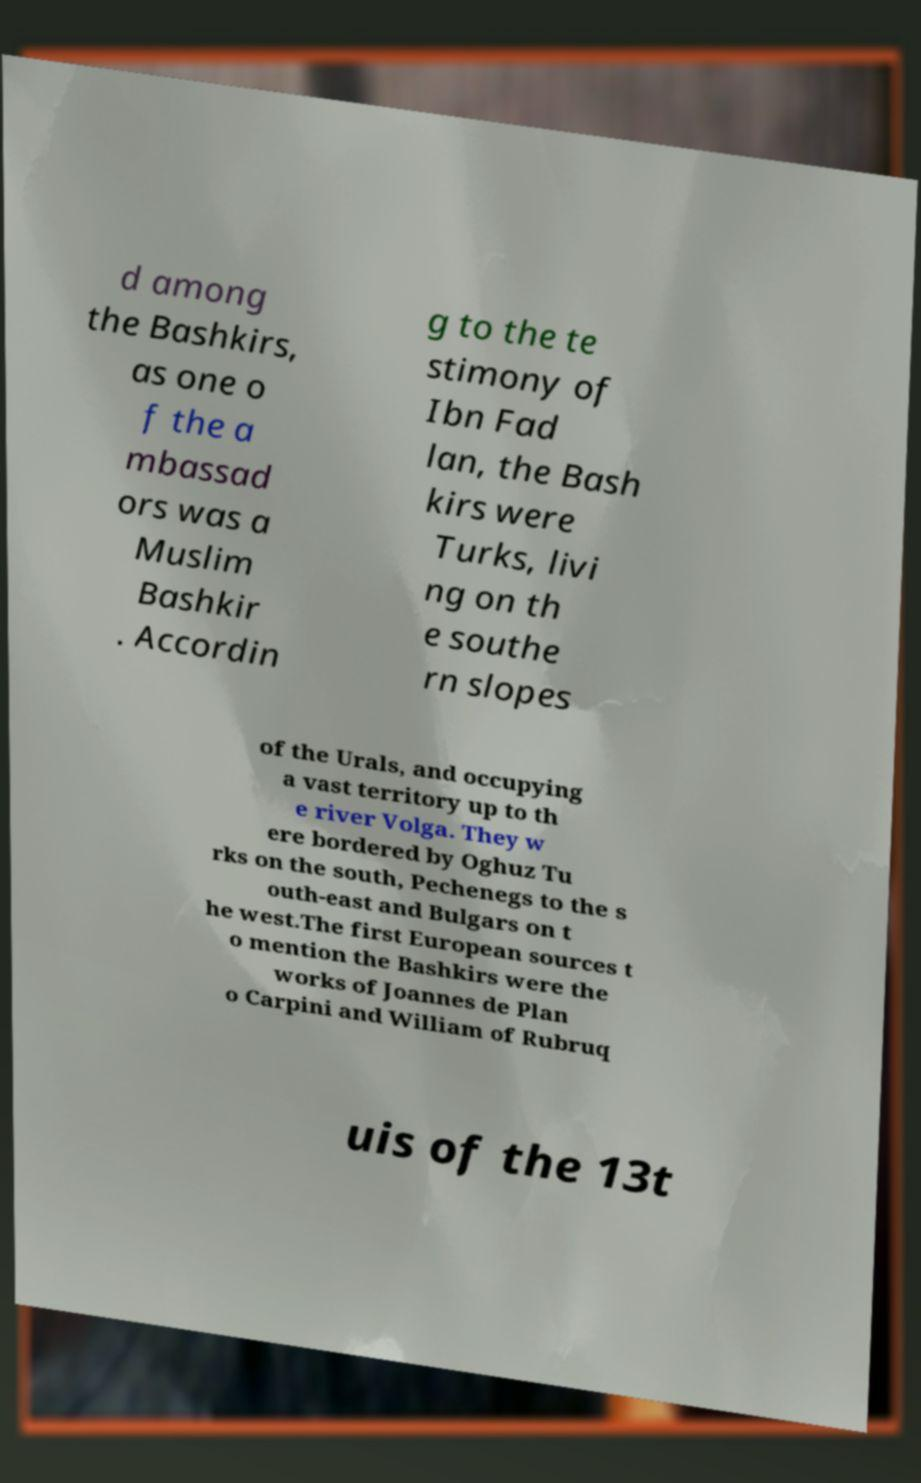Can you read and provide the text displayed in the image?This photo seems to have some interesting text. Can you extract and type it out for me? d among the Bashkirs, as one o f the a mbassad ors was a Muslim Bashkir . Accordin g to the te stimony of Ibn Fad lan, the Bash kirs were Turks, livi ng on th e southe rn slopes of the Urals, and occupying a vast territory up to th e river Volga. They w ere bordered by Oghuz Tu rks on the south, Pechenegs to the s outh-east and Bulgars on t he west.The first European sources t o mention the Bashkirs were the works of Joannes de Plan o Carpini and William of Rubruq uis of the 13t 